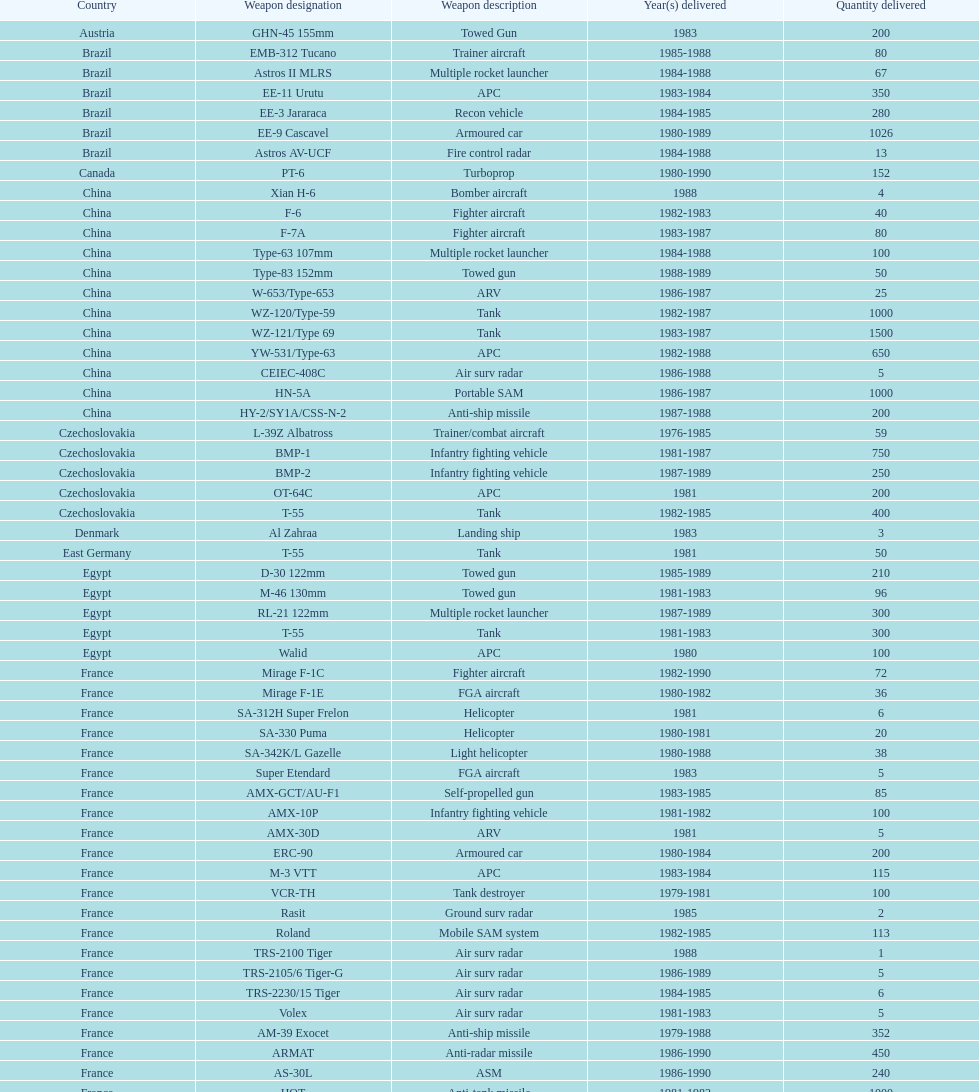Help me parse the entirety of this table. {'header': ['Country', 'Weapon designation', 'Weapon description', 'Year(s) delivered', 'Quantity delivered'], 'rows': [['Austria', 'GHN-45 155mm', 'Towed Gun', '1983', '200'], ['Brazil', 'EMB-312 Tucano', 'Trainer aircraft', '1985-1988', '80'], ['Brazil', 'Astros II MLRS', 'Multiple rocket launcher', '1984-1988', '67'], ['Brazil', 'EE-11 Urutu', 'APC', '1983-1984', '350'], ['Brazil', 'EE-3 Jararaca', 'Recon vehicle', '1984-1985', '280'], ['Brazil', 'EE-9 Cascavel', 'Armoured car', '1980-1989', '1026'], ['Brazil', 'Astros AV-UCF', 'Fire control radar', '1984-1988', '13'], ['Canada', 'PT-6', 'Turboprop', '1980-1990', '152'], ['China', 'Xian H-6', 'Bomber aircraft', '1988', '4'], ['China', 'F-6', 'Fighter aircraft', '1982-1983', '40'], ['China', 'F-7A', 'Fighter aircraft', '1983-1987', '80'], ['China', 'Type-63 107mm', 'Multiple rocket launcher', '1984-1988', '100'], ['China', 'Type-83 152mm', 'Towed gun', '1988-1989', '50'], ['China', 'W-653/Type-653', 'ARV', '1986-1987', '25'], ['China', 'WZ-120/Type-59', 'Tank', '1982-1987', '1000'], ['China', 'WZ-121/Type 69', 'Tank', '1983-1987', '1500'], ['China', 'YW-531/Type-63', 'APC', '1982-1988', '650'], ['China', 'CEIEC-408C', 'Air surv radar', '1986-1988', '5'], ['China', 'HN-5A', 'Portable SAM', '1986-1987', '1000'], ['China', 'HY-2/SY1A/CSS-N-2', 'Anti-ship missile', '1987-1988', '200'], ['Czechoslovakia', 'L-39Z Albatross', 'Trainer/combat aircraft', '1976-1985', '59'], ['Czechoslovakia', 'BMP-1', 'Infantry fighting vehicle', '1981-1987', '750'], ['Czechoslovakia', 'BMP-2', 'Infantry fighting vehicle', '1987-1989', '250'], ['Czechoslovakia', 'OT-64C', 'APC', '1981', '200'], ['Czechoslovakia', 'T-55', 'Tank', '1982-1985', '400'], ['Denmark', 'Al Zahraa', 'Landing ship', '1983', '3'], ['East Germany', 'T-55', 'Tank', '1981', '50'], ['Egypt', 'D-30 122mm', 'Towed gun', '1985-1989', '210'], ['Egypt', 'M-46 130mm', 'Towed gun', '1981-1983', '96'], ['Egypt', 'RL-21 122mm', 'Multiple rocket launcher', '1987-1989', '300'], ['Egypt', 'T-55', 'Tank', '1981-1983', '300'], ['Egypt', 'Walid', 'APC', '1980', '100'], ['France', 'Mirage F-1C', 'Fighter aircraft', '1982-1990', '72'], ['France', 'Mirage F-1E', 'FGA aircraft', '1980-1982', '36'], ['France', 'SA-312H Super Frelon', 'Helicopter', '1981', '6'], ['France', 'SA-330 Puma', 'Helicopter', '1980-1981', '20'], ['France', 'SA-342K/L Gazelle', 'Light helicopter', '1980-1988', '38'], ['France', 'Super Etendard', 'FGA aircraft', '1983', '5'], ['France', 'AMX-GCT/AU-F1', 'Self-propelled gun', '1983-1985', '85'], ['France', 'AMX-10P', 'Infantry fighting vehicle', '1981-1982', '100'], ['France', 'AMX-30D', 'ARV', '1981', '5'], ['France', 'ERC-90', 'Armoured car', '1980-1984', '200'], ['France', 'M-3 VTT', 'APC', '1983-1984', '115'], ['France', 'VCR-TH', 'Tank destroyer', '1979-1981', '100'], ['France', 'Rasit', 'Ground surv radar', '1985', '2'], ['France', 'Roland', 'Mobile SAM system', '1982-1985', '113'], ['France', 'TRS-2100 Tiger', 'Air surv radar', '1988', '1'], ['France', 'TRS-2105/6 Tiger-G', 'Air surv radar', '1986-1989', '5'], ['France', 'TRS-2230/15 Tiger', 'Air surv radar', '1984-1985', '6'], ['France', 'Volex', 'Air surv radar', '1981-1983', '5'], ['France', 'AM-39 Exocet', 'Anti-ship missile', '1979-1988', '352'], ['France', 'ARMAT', 'Anti-radar missile', '1986-1990', '450'], ['France', 'AS-30L', 'ASM', '1986-1990', '240'], ['France', 'HOT', 'Anti-tank missile', '1981-1982', '1000'], ['France', 'R-550 Magic-1', 'SRAAM', '1981-1985', '534'], ['France', 'Roland-2', 'SAM', '1981-1990', '2260'], ['France', 'Super 530F', 'BVRAAM', '1981-1985', '300'], ['West Germany', 'BK-117', 'Helicopter', '1984-1989', '22'], ['West Germany', 'Bo-105C', 'Light Helicopter', '1979-1982', '20'], ['West Germany', 'Bo-105L', 'Light Helicopter', '1988', '6'], ['Hungary', 'PSZH-D-994', 'APC', '1981', '300'], ['Italy', 'A-109 Hirundo', 'Light Helicopter', '1982', '2'], ['Italy', 'S-61', 'Helicopter', '1982', '6'], ['Italy', 'Stromboli class', 'Support ship', '1981', '1'], ['Jordan', 'S-76 Spirit', 'Helicopter', '1985', '2'], ['Poland', 'Mi-2/Hoplite', 'Helicopter', '1984-1985', '15'], ['Poland', 'MT-LB', 'APC', '1983-1990', '750'], ['Poland', 'T-55', 'Tank', '1981-1982', '400'], ['Poland', 'T-72M1', 'Tank', '1982-1990', '500'], ['Romania', 'T-55', 'Tank', '1982-1984', '150'], ['Yugoslavia', 'M-87 Orkan 262mm', 'Multiple rocket launcher', '1988', '2'], ['South Africa', 'G-5 155mm', 'Towed gun', '1985-1988', '200'], ['Switzerland', 'PC-7 Turbo trainer', 'Trainer aircraft', '1980-1983', '52'], ['Switzerland', 'PC-9', 'Trainer aircraft', '1987-1990', '20'], ['Switzerland', 'Roland', 'APC/IFV', '1981', '100'], ['United Kingdom', 'Chieftain/ARV', 'ARV', '1982', '29'], ['United Kingdom', 'Cymbeline', 'Arty locating radar', '1986-1988', '10'], ['United States', 'MD-500MD Defender', 'Light Helicopter', '1983', '30'], ['United States', 'Hughes-300/TH-55', 'Light Helicopter', '1983', '30'], ['United States', 'MD-530F', 'Light Helicopter', '1986', '26'], ['United States', 'Bell 214ST', 'Helicopter', '1988', '31'], ['Soviet Union', 'Il-76M/Candid-B', 'Strategic airlifter', '1978-1984', '33'], ['Soviet Union', 'Mi-24D/Mi-25/Hind-D', 'Attack helicopter', '1978-1984', '12'], ['Soviet Union', 'Mi-8/Mi-17/Hip-H', 'Transport helicopter', '1986-1987', '37'], ['Soviet Union', 'Mi-8TV/Hip-F', 'Transport helicopter', '1984', '30'], ['Soviet Union', 'Mig-21bis/Fishbed-N', 'Fighter aircraft', '1983-1984', '61'], ['Soviet Union', 'Mig-23BN/Flogger-H', 'FGA aircraft', '1984-1985', '50'], ['Soviet Union', 'Mig-25P/Foxbat-A', 'Interceptor aircraft', '1980-1985', '55'], ['Soviet Union', 'Mig-25RB/Foxbat-B', 'Recon aircraft', '1982', '8'], ['Soviet Union', 'Mig-29/Fulcrum-A', 'Fighter aircraft', '1986-1989', '41'], ['Soviet Union', 'Su-22/Fitter-H/J/K', 'FGA aircraft', '1986-1987', '61'], ['Soviet Union', 'Su-25/Frogfoot-A', 'Ground attack aircraft', '1986-1987', '84'], ['Soviet Union', '2A36 152mm', 'Towed gun', '1986-1988', '180'], ['Soviet Union', '2S1 122mm', 'Self-Propelled Howitzer', '1980-1989', '150'], ['Soviet Union', '2S3 152mm', 'Self-propelled gun', '1980-1989', '150'], ['Soviet Union', '2S4 240mm', 'Self-propelled mortar', '1983', '10'], ['Soviet Union', '9P117/SS-1 Scud TEL', 'SSM launcher', '1983-1984', '10'], ['Soviet Union', 'BM-21 Grad 122mm', 'Multiple rocket launcher', '1983-1988', '560'], ['Soviet Union', 'D-30 122mm', 'Towed gun', '1982-1988', '576'], ['Soviet Union', 'M-240 240mm', 'Mortar', '1981', '25'], ['Soviet Union', 'M-46 130mm', 'Towed Gun', '1982-1987', '576'], ['Soviet Union', '9K35 Strela-10/SA-13', 'AAV(M)', '1985', '30'], ['Soviet Union', 'BMD-1', 'IFV', '1981', '10'], ['Soviet Union', 'PT-76', 'Light tank', '1984', '200'], ['Soviet Union', 'SA-9/9P31', 'AAV(M)', '1982-1985', '160'], ['Soviet Union', 'Long Track', 'Air surv radar', '1980-1984', '10'], ['Soviet Union', 'SA-8b/9K33M Osa AK', 'Mobile SAM system', '1982-1985', '50'], ['Soviet Union', 'Thin Skin', 'Air surv radar', '1980-1984', '5'], ['Soviet Union', '9M111/AT-4 Spigot', 'Anti-tank missile', '1986-1989', '3000'], ['Soviet Union', '9M37/SA-13 Gopher', 'SAM', '1985-1986', '960'], ['Soviet Union', 'KSR-5/AS-6 Kingfish', 'Anti-ship missile', '1984', '36'], ['Soviet Union', 'Kh-28/AS-9 Kyle', 'Anti-radar missile', '1983-1988', '250'], ['Soviet Union', 'R-13S/AA2S Atoll', 'SRAAM', '1984-1987', '1080'], ['Soviet Union', 'R-17/SS-1c Scud-B', 'SSM', '1982-1988', '840'], ['Soviet Union', 'R-27/AA-10 Alamo', 'BVRAAM', '1986-1989', '246'], ['Soviet Union', 'R-40R/AA-6 Acrid', 'BVRAAM', '1980-1985', '660'], ['Soviet Union', 'R-60/AA-8 Aphid', 'SRAAM', '1986-1989', '582'], ['Soviet Union', 'SA-8b Gecko/9M33M', 'SAM', '1982-1985', '1290'], ['Soviet Union', 'SA-9 Gaskin/9M31', 'SAM', '1982-1985', '1920'], ['Soviet Union', 'Strela-3/SA-14 Gremlin', 'Portable SAM', '1987-1988', '500']]} Which country had the largest number of towed guns delivered? Soviet Union. 